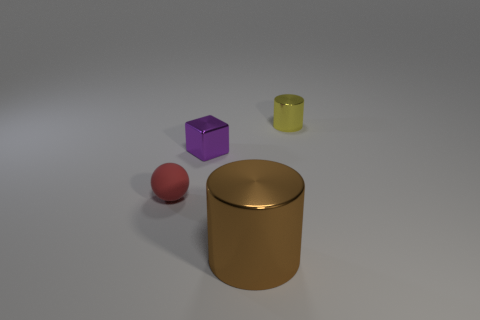What is the color of the other metallic thing that is the same shape as the brown thing?
Offer a terse response. Yellow. Is the metallic cube the same color as the big metal object?
Make the answer very short. No. What number of rubber objects are either big cylinders or tiny red objects?
Offer a terse response. 1. What number of other objects are the same shape as the brown metal object?
Give a very brief answer. 1. Is the number of tiny purple blocks greater than the number of small things?
Provide a short and direct response. No. There is a thing that is left of the small shiny object to the left of the big thing on the right side of the purple cube; what size is it?
Your answer should be compact. Small. How big is the ball in front of the tiny yellow object?
Give a very brief answer. Small. How many objects are either tiny blue things or small things that are in front of the yellow metallic thing?
Your response must be concise. 2. What number of other things are the same size as the purple cube?
Your response must be concise. 2. There is a yellow thing that is the same shape as the big brown shiny object; what is it made of?
Your response must be concise. Metal. 